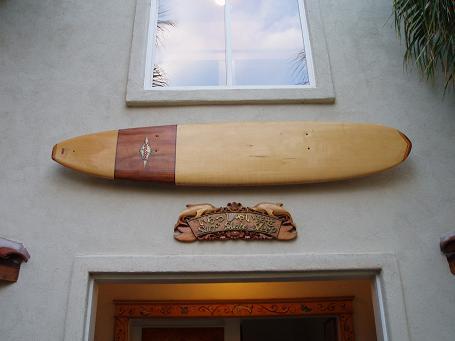What does it say under the board?
Quick response, please. Nothing. What kind of tree is that?
Keep it brief. Palm. What color is the stripe on the board?
Concise answer only. Brown. 